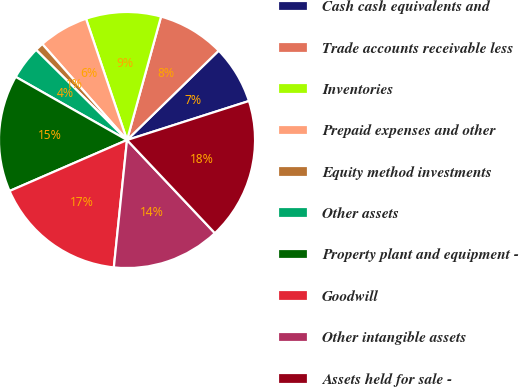<chart> <loc_0><loc_0><loc_500><loc_500><pie_chart><fcel>Cash cash equivalents and<fcel>Trade accounts receivable less<fcel>Inventories<fcel>Prepaid expenses and other<fcel>Equity method investments<fcel>Other assets<fcel>Property plant and equipment -<fcel>Goodwill<fcel>Other intangible assets<fcel>Assets held for sale -<nl><fcel>7.37%<fcel>8.42%<fcel>9.47%<fcel>6.32%<fcel>1.06%<fcel>4.22%<fcel>14.73%<fcel>16.84%<fcel>13.68%<fcel>17.89%<nl></chart> 